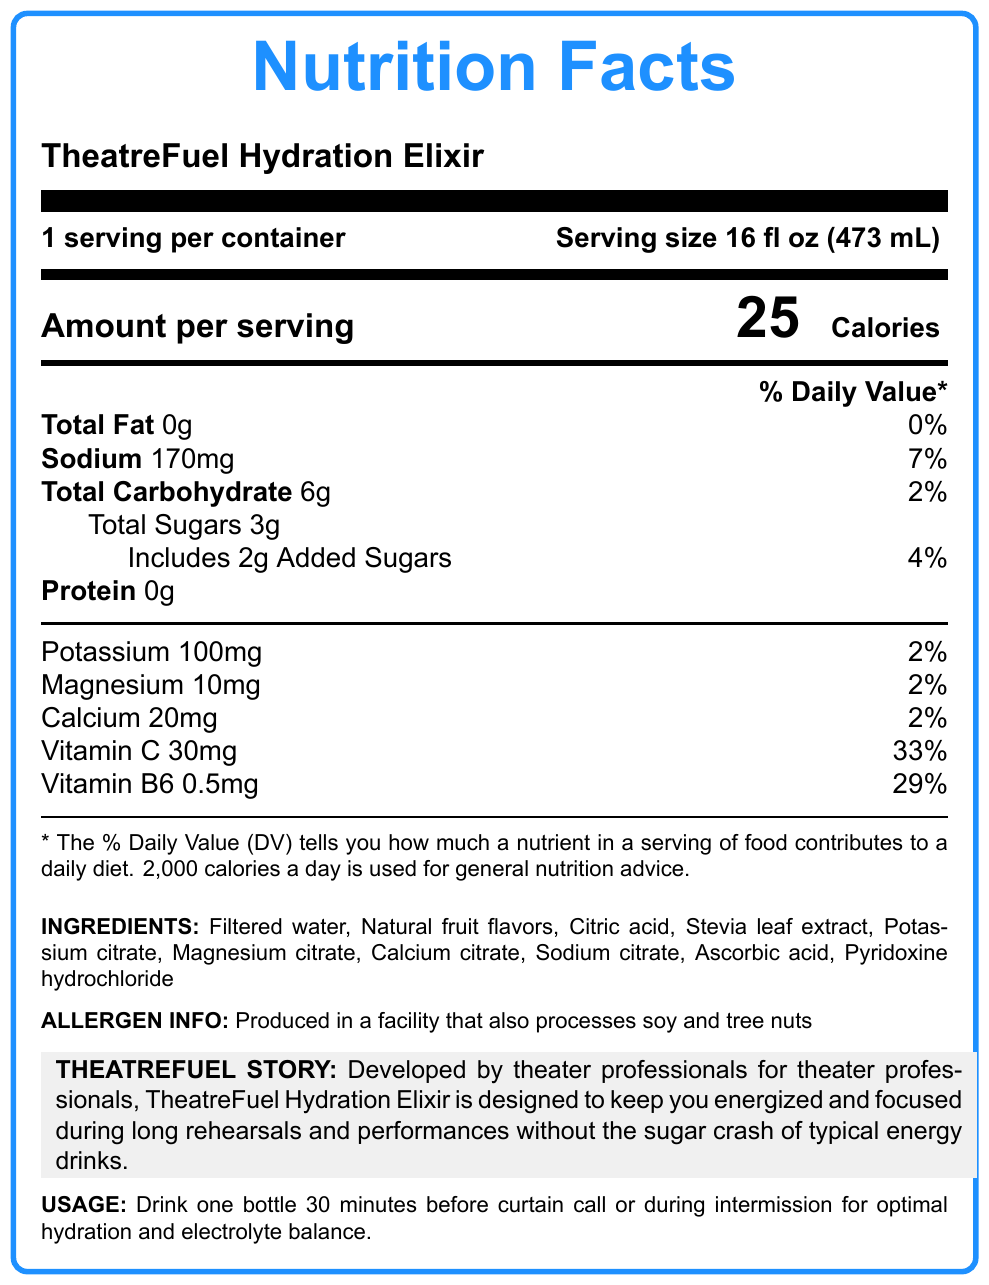What is the serving size for TheatreFuel Hydration Elixir? The serving size is directly mentioned at the top of the nutrition facts section.
Answer: 16 fl oz (473 mL) How many calories are there per serving? The number of calories per serving is prominently displayed in the "Amount per serving" section.
Answer: 25 How much sodium does one serving contain? The sodium content is listed under the % Daily Value column.
Answer: 170mg How many grams of total sugars are in one serving? The total sugars content is listed under the "Total Carbohydrate" section.
Answer: 3g What are the other ingredients in TheatreFuel Hydration Elixir? The ingredients are listed towards the bottom of the document.
Answer: Filtered water, Natural fruit flavors, Citric acid, Stevia leaf extract, Potassium citrate, Magnesium citrate, Calcium citrate, Sodium citrate, Ascorbic acid, Pyridoxine hydrochloride How much Vitamin C is in one serving of TheatreFuel Hydration Elixir? A. 15mg B. 20mg C. 30mg D. 25mg The amount of Vitamin C per serving is listed under its % Daily Value section.
Answer: C. 30mg Which one of the following minerals is not included in the ingredients list? A. Magnesium B. Zinc C. Calcium D. Sodium Magnesium, Calcium, and Sodium are all listed in the ingredients, but Zinc is not.
Answer: B. Zinc Is TheatreFuel Hydration Elixir produced in a facility that processes soy and tree nuts? The allergen information states that it is produced in such a facility.
Answer: Yes Describe the main idea of the TheatreFuel Hydration Elixir document. The explanation includes all key components of the document, integrating the product’s intent, nutritional value, and guidance notes.
Answer: The document provides the nutrition facts and product information for TheatreFuel Hydration Elixir, highlighting its low calories, electrolyte content, and minimal sugars, along with all ingredients, allergen information, and usage instructions. What is the recommended usage for optimal hydration and electrolyte balance? The usage instructions are provided at the bottom of the document.
Answer: Drink one bottle 30 minutes before curtain call or during intermission Which nutritional component has the highest % Daily Value? The % Daily Value for Vitamin C is the highest, mentioned at 33%.
Answer: Vitamin C with 33% Can we determine the exact concentration of natural fruit flavors in the drink? The exact concentration of natural fruit flavors is not specified in the document.
Answer: Cannot be determined What is the % Daily Value for Total Carbohydrates in this drink? This information is listed next to the "Total Carbohydrate" section.
Answer: 2% 